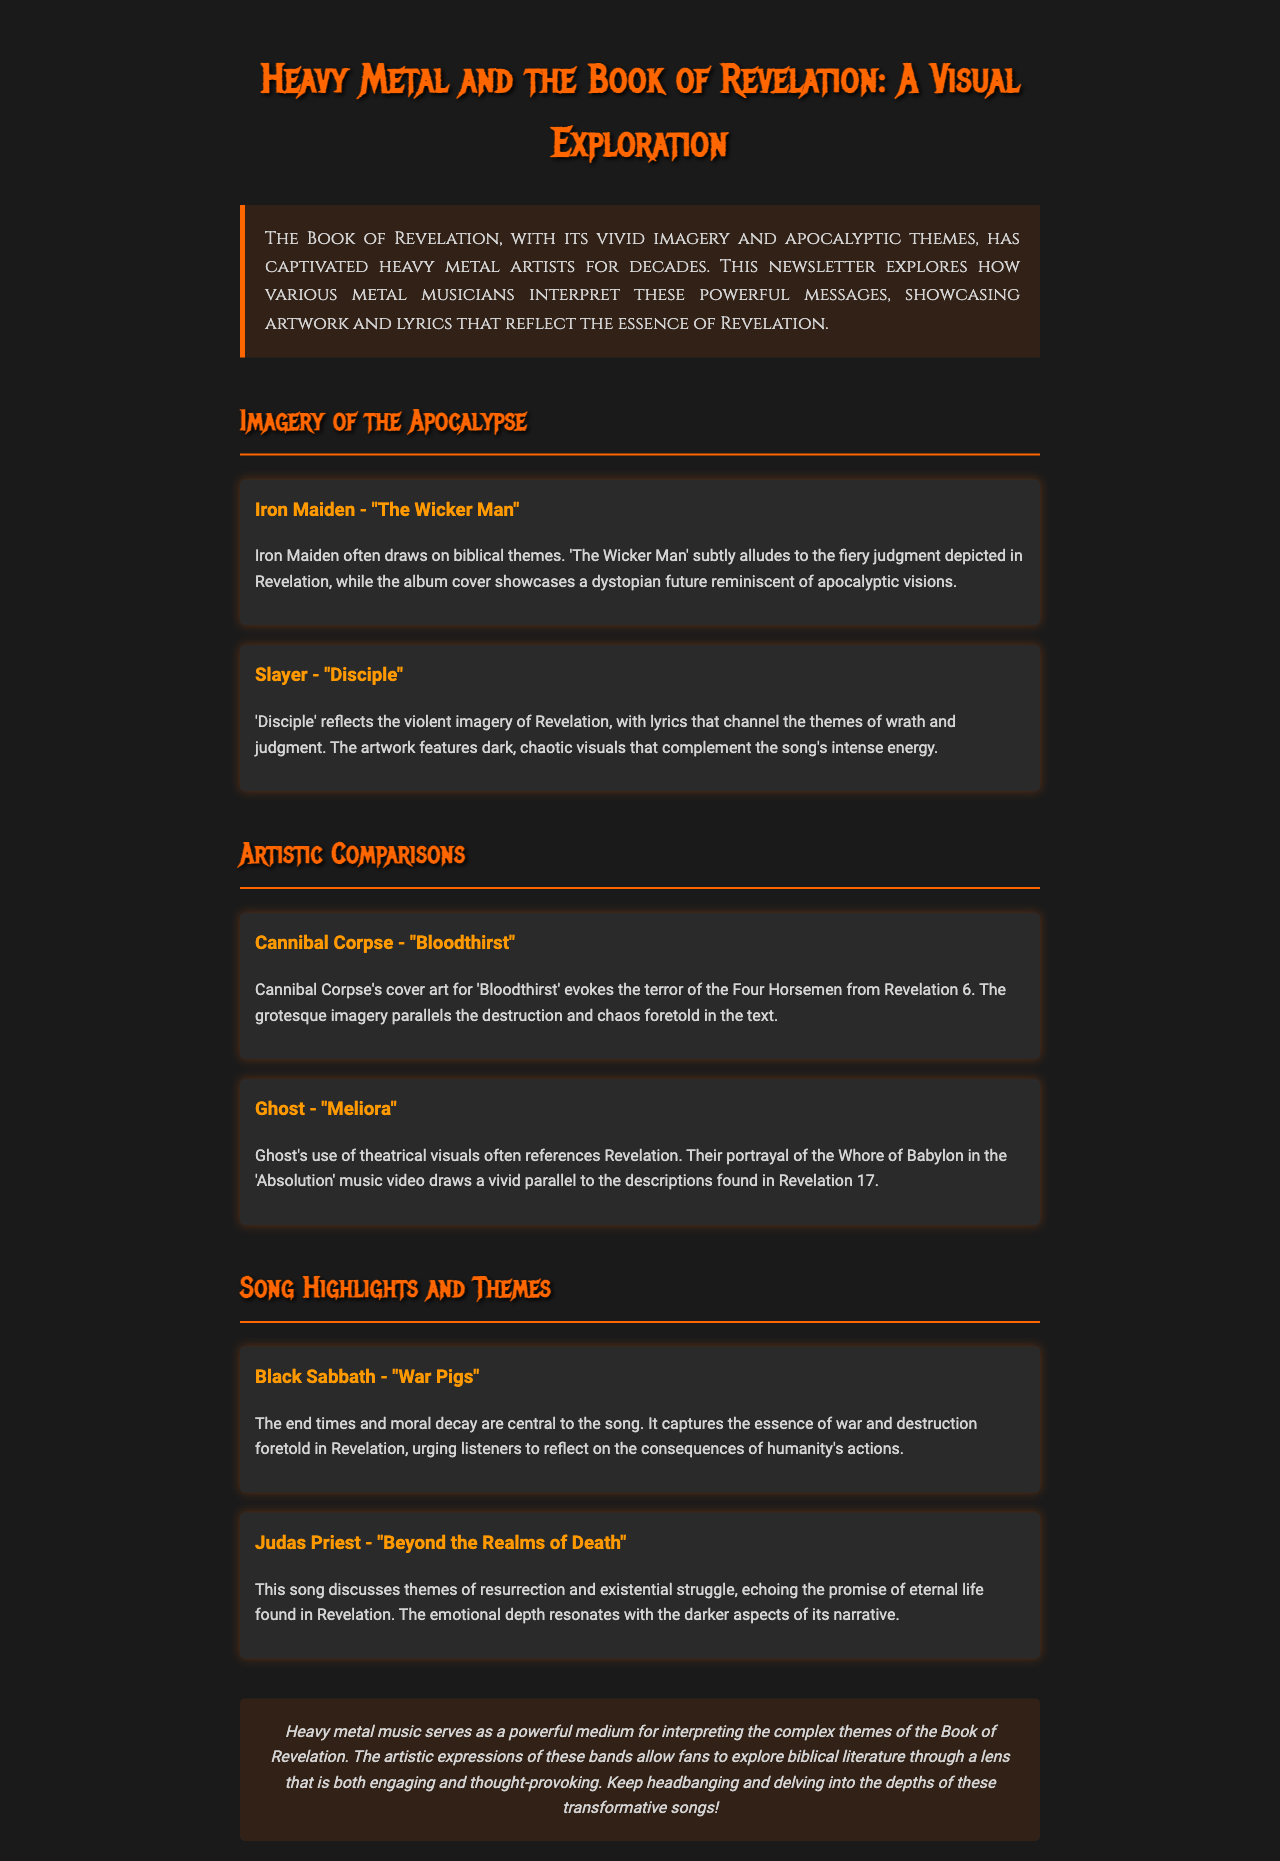what is the title of the newsletter? The title of the newsletter is presented prominently at the top of the document.
Answer: Heavy Metal and the Book of Revelation: A Visual Exploration which band is associated with the song "The Wicker Man"? The band that performs "The Wicker Man" is mentioned in a section about imagery in the document.
Answer: Iron Maiden what biblical theme is reflected in Slayer's "Disciple"? The document discusses the themes conveyed in Slayer's "Disciple," particularly regarding the imagery used.
Answer: wrath and judgment which song by Black Sabbath discusses themes of war? This question targets specifics about songs that have thematic relevance as mentioned in the newsletter.
Answer: War Pigs what artist's cover art evokes the Four Horsemen from Revelation? The document provides details about artwork that parallels biblical imagery, specifically the Four Horsemen.
Answer: Cannibal Corpse how many songs by Judas Priest are mentioned in the newsletter? The count of songs mentioned in relation to Judas Priest reveals the document's focus on specific tracks.
Answer: One which visual element is emphasized in Ghost's music video "Absolution"? The newsletter highlights a specific character referenced in Ghost's visuals that corresponds with biblical narrative.
Answer: Whore of Babylon what color is used for the newsletter’s main title? The color used for the main title serves as a visual cue and branding element throughout the document.
Answer: orange what is the main focus of the conclusion section? The conclusion summarizes the document's exploration of themes and artistic interpretations found within metal music.
Answer: artistic expressions 